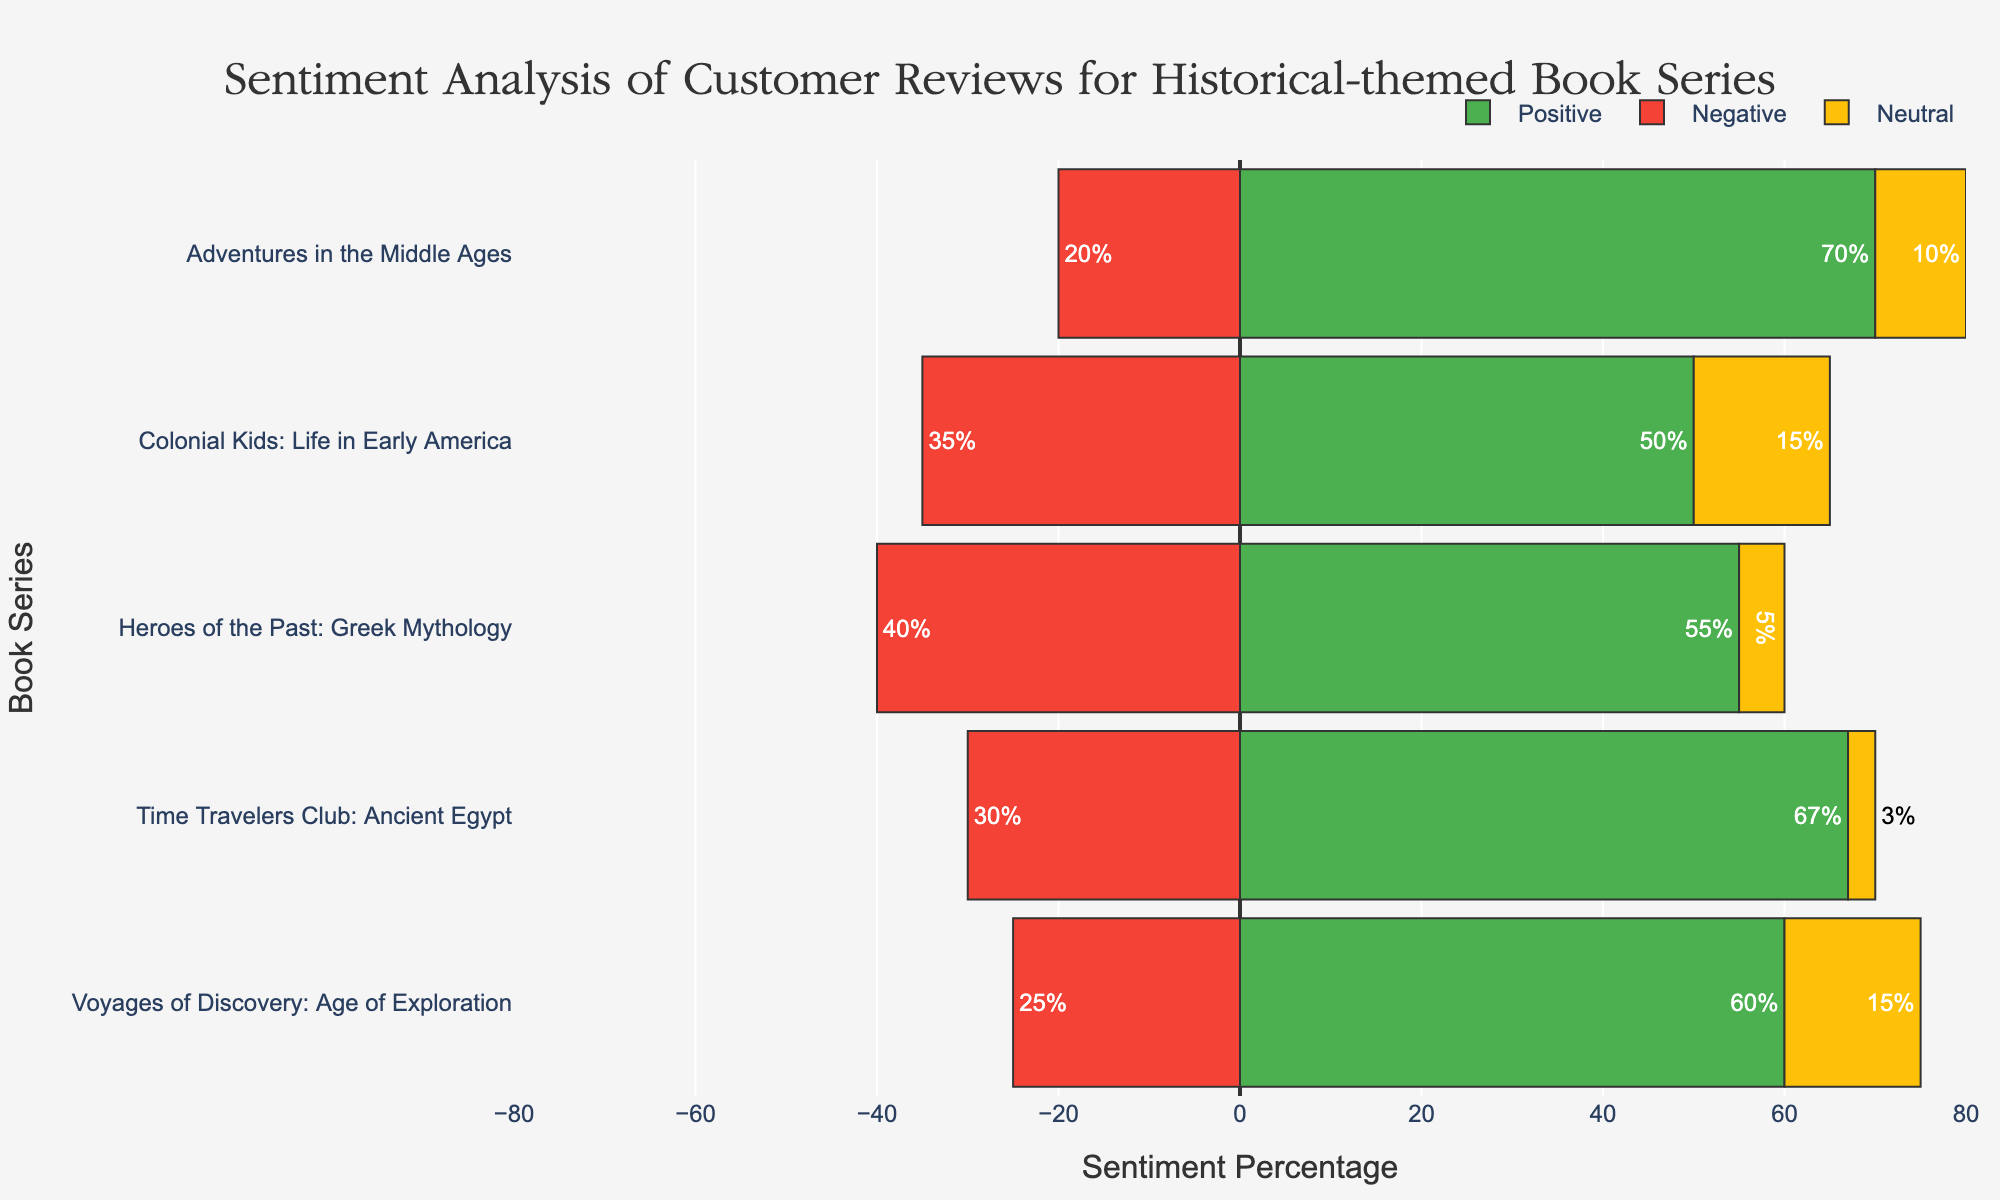Which book series has the highest positive sentiment? Look at all bars labeled "Positive" and identify which is the tallest. For the "Adventures in the Middle Ages" series, the Positive bar reaches 70%.
Answer: Adventures in the Middle Ages Which book series has the closest percentages of positive and negative sentiments? Compare the positive and negative sentiment values for all book series. "Heroes of the Past: Greek Mythology" has 55% positive and 40% negative, which are the closest in value.
Answer: Heroes of the Past: Greek Mythology What is the total sentiment for all book series combined? Sum up the absolute values of all sentiment percentages across all book series. The sums are 67+30+3+55+40+5+70+20+10+60+25+15+50+35+15.
Answer: 500 Which book series has the least neutral sentiment? Look at the Neutral bars and identify the shortest one. The shortest Neutral bar is for "Time Travelers Club: Ancient Egypt" at 3%.
Answer: Time Travelers Club: Ancient Egypt Compare the negative sentiment of "Time Travelers Club: Ancient Egypt" and "Colonial Kids: Life in Early America." Which one is higher? Compare the lengths of the Negative bars for both series. "Colonial Kids: Life in Early America" has a Negative sentiment of 35%, which is higher than "Time Travelers Club: Ancient Egypt" at 30%.
Answer: Colonial Kids: Life in Early America Calculate the ratio of positive to total sentiment for the "Voyages of Discovery: Age of Exploration" series. The total sentiment percentage is 100% (since it encompasses positive, negative, and neutral). The positive sentiment is 60%, so the ratio is 60/100.
Answer: 0.60 Which book series has the highest overall negative sentiment in value? Look for the longest Negative bar. The longest bar for negative sentiment is for "Heroes of the Past: Greek Mythology" with 40%.
Answer: Heroes of the Past: Greek Mythology Sum and compare the neutral sentiments for all book series. Add up the neutral sentiment values: 3 (Ancient Egypt) + 5 (Greek Mythology) + 10 (Middle Ages) + 15 (Age of Exploration) + 15 (Early America). Compare these with each other. The total is 48%.
Answer: 48 Which book series has the largest difference between positive and negative sentiments, and what is that difference? Calculate the difference for each book series between its positive and negative sentiments. The differences are: "Ancient Egypt" = 67 - 30, "Greek Mythology" = 55 - 40, "Middle Ages" = 70 - 20, "Age of Exploration" = 60 - 25, "Early America" = 50 - 35. The largest difference, 50, is for "Adventures in the Middle Ages."
Answer: Adventures in the Middle Ages, 50 